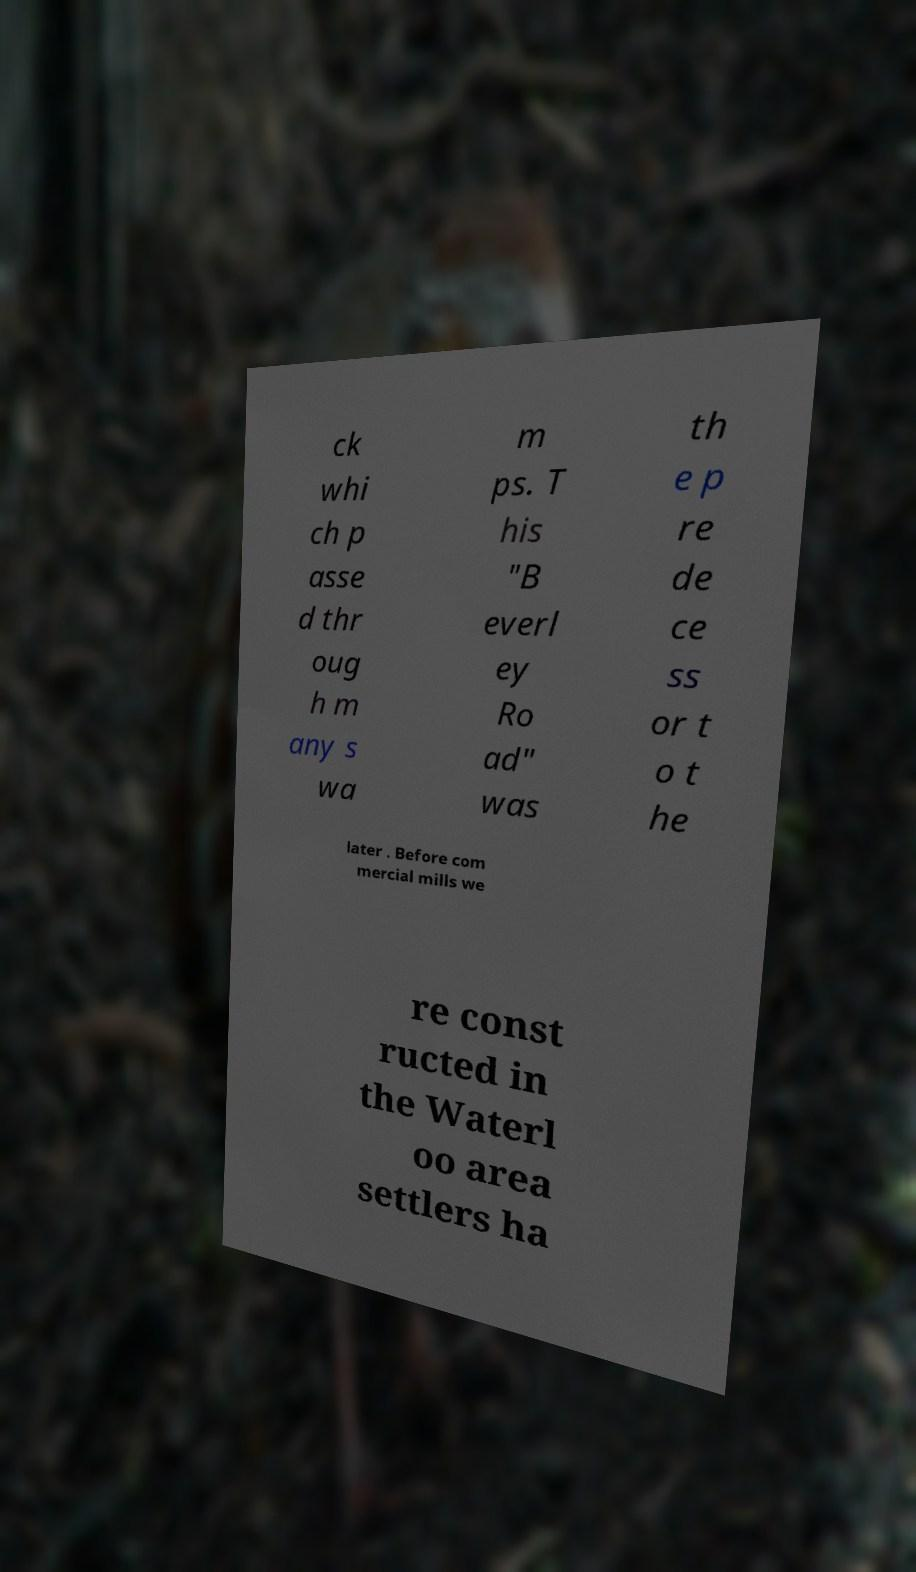Please read and relay the text visible in this image. What does it say? ck whi ch p asse d thr oug h m any s wa m ps. T his "B everl ey Ro ad" was th e p re de ce ss or t o t he later . Before com mercial mills we re const ructed in the Waterl oo area settlers ha 